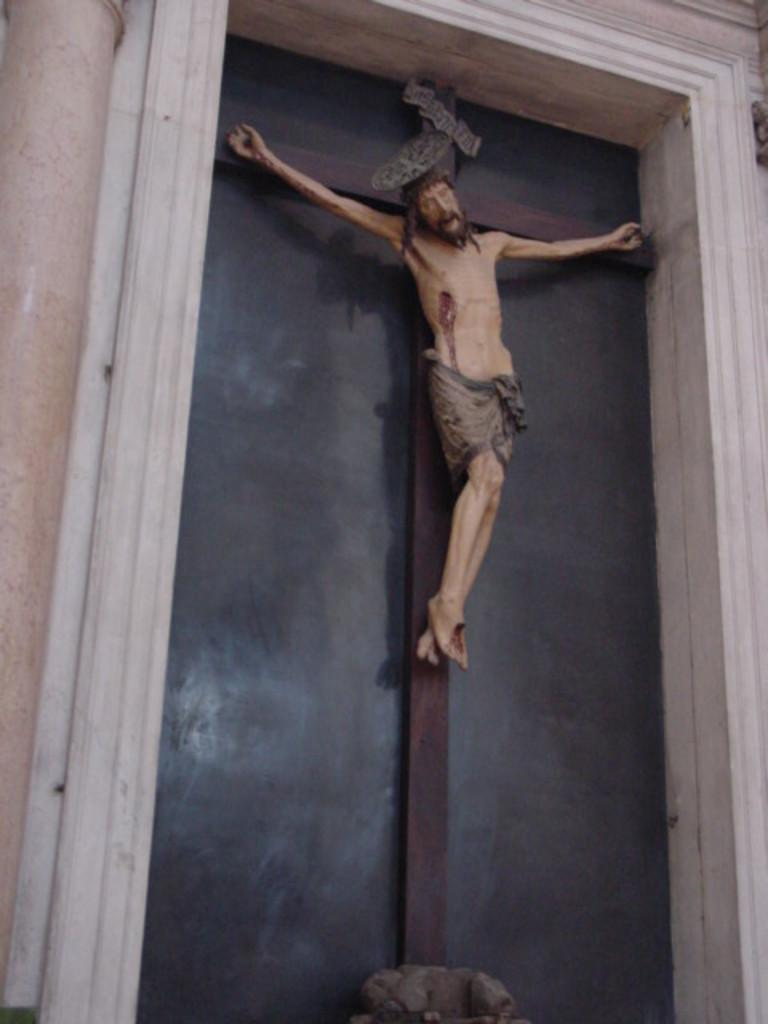What type of pipe can be seen in the image? There is a cream-colored pipe in the image. What is the color of the wall in the image? There is a black-colored wall in the image. What kind of object is depicted as a person in the image? There is a statue of a person in the image. What colors are used for the statue? The statue is cream and brown in color. How is the statue positioned in the image? The statue is hanged on wooden logs. What type of jeans is the statue wearing in the image? There is no mention of jeans in the image, as the statue is depicted as a person and not wearing any clothing. How does the statue join the society in the image? The statue is not a living being and cannot join any society; it is a stationary object in the image. 